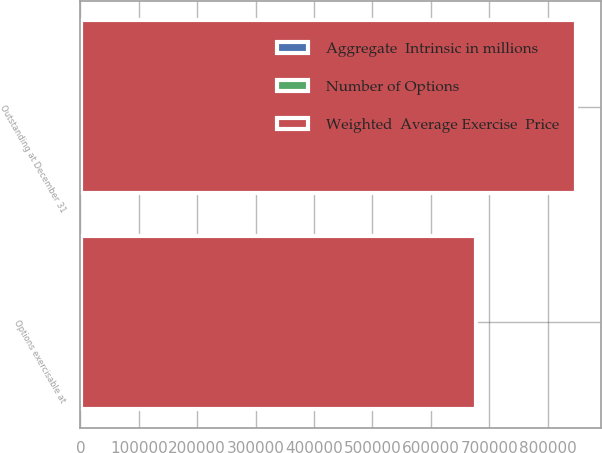Convert chart. <chart><loc_0><loc_0><loc_500><loc_500><stacked_bar_chart><ecel><fcel>Outstanding at December 31<fcel>Options exercisable at<nl><fcel>Weighted  Average Exercise  Price<fcel>847830<fcel>676202<nl><fcel>Number of Options<fcel>260.88<fcel>208.01<nl><fcel>Aggregate  Intrinsic in millions<fcel>264<fcel>242.8<nl></chart> 